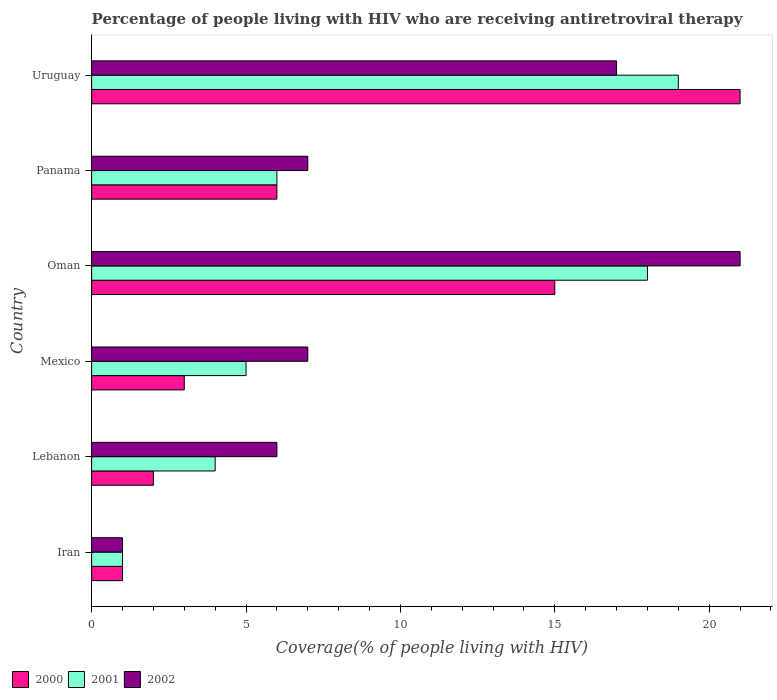How many different coloured bars are there?
Keep it short and to the point. 3. How many groups of bars are there?
Give a very brief answer. 6. How many bars are there on the 2nd tick from the top?
Your answer should be very brief. 3. What is the label of the 2nd group of bars from the top?
Your answer should be compact. Panama. Across all countries, what is the maximum percentage of the HIV infected people who are receiving antiretroviral therapy in 2000?
Your answer should be compact. 21. Across all countries, what is the minimum percentage of the HIV infected people who are receiving antiretroviral therapy in 2000?
Make the answer very short. 1. In which country was the percentage of the HIV infected people who are receiving antiretroviral therapy in 2000 maximum?
Offer a very short reply. Uruguay. In which country was the percentage of the HIV infected people who are receiving antiretroviral therapy in 2002 minimum?
Offer a very short reply. Iran. What is the average percentage of the HIV infected people who are receiving antiretroviral therapy in 2001 per country?
Offer a terse response. 8.83. In how many countries, is the percentage of the HIV infected people who are receiving antiretroviral therapy in 2002 greater than 5 %?
Ensure brevity in your answer.  5. What is the ratio of the percentage of the HIV infected people who are receiving antiretroviral therapy in 2000 in Panama to that in Uruguay?
Provide a succinct answer. 0.29. Is the percentage of the HIV infected people who are receiving antiretroviral therapy in 2000 in Iran less than that in Uruguay?
Your answer should be very brief. Yes. Is the difference between the percentage of the HIV infected people who are receiving antiretroviral therapy in 2001 in Mexico and Uruguay greater than the difference between the percentage of the HIV infected people who are receiving antiretroviral therapy in 2002 in Mexico and Uruguay?
Give a very brief answer. No. What is the difference between the highest and the lowest percentage of the HIV infected people who are receiving antiretroviral therapy in 2000?
Your response must be concise. 20. Is the sum of the percentage of the HIV infected people who are receiving antiretroviral therapy in 2000 in Iran and Panama greater than the maximum percentage of the HIV infected people who are receiving antiretroviral therapy in 2002 across all countries?
Keep it short and to the point. No. What does the 2nd bar from the top in Uruguay represents?
Your answer should be very brief. 2001. Are all the bars in the graph horizontal?
Ensure brevity in your answer.  Yes. How many countries are there in the graph?
Provide a short and direct response. 6. What is the difference between two consecutive major ticks on the X-axis?
Ensure brevity in your answer.  5. Are the values on the major ticks of X-axis written in scientific E-notation?
Make the answer very short. No. Does the graph contain any zero values?
Keep it short and to the point. No. Does the graph contain grids?
Offer a very short reply. No. How are the legend labels stacked?
Provide a succinct answer. Horizontal. What is the title of the graph?
Your response must be concise. Percentage of people living with HIV who are receiving antiretroviral therapy. Does "1985" appear as one of the legend labels in the graph?
Provide a short and direct response. No. What is the label or title of the X-axis?
Provide a short and direct response. Coverage(% of people living with HIV). What is the label or title of the Y-axis?
Your answer should be very brief. Country. What is the Coverage(% of people living with HIV) in 2001 in Iran?
Make the answer very short. 1. What is the Coverage(% of people living with HIV) of 2002 in Iran?
Provide a succinct answer. 1. What is the Coverage(% of people living with HIV) of 2000 in Lebanon?
Your answer should be very brief. 2. What is the Coverage(% of people living with HIV) in 2001 in Lebanon?
Your response must be concise. 4. What is the Coverage(% of people living with HIV) of 2002 in Lebanon?
Your answer should be compact. 6. What is the Coverage(% of people living with HIV) in 2000 in Mexico?
Ensure brevity in your answer.  3. What is the Coverage(% of people living with HIV) in 2001 in Mexico?
Offer a terse response. 5. What is the Coverage(% of people living with HIV) in 2002 in Mexico?
Give a very brief answer. 7. What is the Coverage(% of people living with HIV) in 2000 in Oman?
Ensure brevity in your answer.  15. What is the Coverage(% of people living with HIV) of 2001 in Panama?
Provide a succinct answer. 6. What is the Coverage(% of people living with HIV) of 2002 in Panama?
Offer a terse response. 7. What is the Coverage(% of people living with HIV) of 2002 in Uruguay?
Your response must be concise. 17. Across all countries, what is the maximum Coverage(% of people living with HIV) of 2000?
Provide a short and direct response. 21. Across all countries, what is the maximum Coverage(% of people living with HIV) of 2001?
Ensure brevity in your answer.  19. Across all countries, what is the minimum Coverage(% of people living with HIV) of 2002?
Keep it short and to the point. 1. What is the difference between the Coverage(% of people living with HIV) of 2001 in Iran and that in Lebanon?
Your answer should be compact. -3. What is the difference between the Coverage(% of people living with HIV) of 2002 in Iran and that in Lebanon?
Your answer should be very brief. -5. What is the difference between the Coverage(% of people living with HIV) of 2002 in Iran and that in Mexico?
Offer a very short reply. -6. What is the difference between the Coverage(% of people living with HIV) in 2000 in Iran and that in Oman?
Keep it short and to the point. -14. What is the difference between the Coverage(% of people living with HIV) of 2002 in Iran and that in Oman?
Offer a very short reply. -20. What is the difference between the Coverage(% of people living with HIV) of 2001 in Iran and that in Panama?
Make the answer very short. -5. What is the difference between the Coverage(% of people living with HIV) in 2000 in Lebanon and that in Mexico?
Make the answer very short. -1. What is the difference between the Coverage(% of people living with HIV) of 2002 in Lebanon and that in Mexico?
Give a very brief answer. -1. What is the difference between the Coverage(% of people living with HIV) of 2001 in Lebanon and that in Oman?
Ensure brevity in your answer.  -14. What is the difference between the Coverage(% of people living with HIV) in 2002 in Lebanon and that in Oman?
Provide a succinct answer. -15. What is the difference between the Coverage(% of people living with HIV) of 2000 in Lebanon and that in Uruguay?
Offer a terse response. -19. What is the difference between the Coverage(% of people living with HIV) in 2001 in Mexico and that in Panama?
Offer a very short reply. -1. What is the difference between the Coverage(% of people living with HIV) of 2002 in Mexico and that in Panama?
Provide a succinct answer. 0. What is the difference between the Coverage(% of people living with HIV) in 2002 in Mexico and that in Uruguay?
Your answer should be compact. -10. What is the difference between the Coverage(% of people living with HIV) in 2001 in Oman and that in Panama?
Your answer should be very brief. 12. What is the difference between the Coverage(% of people living with HIV) in 2002 in Oman and that in Panama?
Provide a short and direct response. 14. What is the difference between the Coverage(% of people living with HIV) in 2000 in Oman and that in Uruguay?
Make the answer very short. -6. What is the difference between the Coverage(% of people living with HIV) of 2001 in Oman and that in Uruguay?
Keep it short and to the point. -1. What is the difference between the Coverage(% of people living with HIV) in 2000 in Panama and that in Uruguay?
Your response must be concise. -15. What is the difference between the Coverage(% of people living with HIV) in 2002 in Panama and that in Uruguay?
Give a very brief answer. -10. What is the difference between the Coverage(% of people living with HIV) in 2000 in Iran and the Coverage(% of people living with HIV) in 2001 in Lebanon?
Offer a terse response. -3. What is the difference between the Coverage(% of people living with HIV) in 2001 in Iran and the Coverage(% of people living with HIV) in 2002 in Lebanon?
Keep it short and to the point. -5. What is the difference between the Coverage(% of people living with HIV) of 2000 in Iran and the Coverage(% of people living with HIV) of 2001 in Oman?
Keep it short and to the point. -17. What is the difference between the Coverage(% of people living with HIV) of 2000 in Iran and the Coverage(% of people living with HIV) of 2001 in Panama?
Make the answer very short. -5. What is the difference between the Coverage(% of people living with HIV) of 2000 in Iran and the Coverage(% of people living with HIV) of 2002 in Panama?
Your answer should be compact. -6. What is the difference between the Coverage(% of people living with HIV) in 2001 in Iran and the Coverage(% of people living with HIV) in 2002 in Panama?
Your answer should be very brief. -6. What is the difference between the Coverage(% of people living with HIV) of 2000 in Iran and the Coverage(% of people living with HIV) of 2001 in Uruguay?
Keep it short and to the point. -18. What is the difference between the Coverage(% of people living with HIV) in 2001 in Iran and the Coverage(% of people living with HIV) in 2002 in Uruguay?
Keep it short and to the point. -16. What is the difference between the Coverage(% of people living with HIV) of 2000 in Lebanon and the Coverage(% of people living with HIV) of 2001 in Mexico?
Keep it short and to the point. -3. What is the difference between the Coverage(% of people living with HIV) in 2000 in Lebanon and the Coverage(% of people living with HIV) in 2002 in Mexico?
Give a very brief answer. -5. What is the difference between the Coverage(% of people living with HIV) of 2000 in Lebanon and the Coverage(% of people living with HIV) of 2002 in Oman?
Give a very brief answer. -19. What is the difference between the Coverage(% of people living with HIV) of 2001 in Lebanon and the Coverage(% of people living with HIV) of 2002 in Oman?
Your answer should be very brief. -17. What is the difference between the Coverage(% of people living with HIV) in 2000 in Lebanon and the Coverage(% of people living with HIV) in 2001 in Panama?
Your answer should be compact. -4. What is the difference between the Coverage(% of people living with HIV) in 2000 in Lebanon and the Coverage(% of people living with HIV) in 2002 in Panama?
Make the answer very short. -5. What is the difference between the Coverage(% of people living with HIV) of 2000 in Lebanon and the Coverage(% of people living with HIV) of 2002 in Uruguay?
Offer a very short reply. -15. What is the difference between the Coverage(% of people living with HIV) of 2000 in Mexico and the Coverage(% of people living with HIV) of 2001 in Oman?
Keep it short and to the point. -15. What is the difference between the Coverage(% of people living with HIV) of 2000 in Mexico and the Coverage(% of people living with HIV) of 2002 in Oman?
Your answer should be compact. -18. What is the difference between the Coverage(% of people living with HIV) in 2001 in Mexico and the Coverage(% of people living with HIV) in 2002 in Oman?
Your response must be concise. -16. What is the difference between the Coverage(% of people living with HIV) in 2001 in Mexico and the Coverage(% of people living with HIV) in 2002 in Panama?
Your response must be concise. -2. What is the difference between the Coverage(% of people living with HIV) of 2000 in Mexico and the Coverage(% of people living with HIV) of 2001 in Uruguay?
Offer a terse response. -16. What is the difference between the Coverage(% of people living with HIV) in 2000 in Mexico and the Coverage(% of people living with HIV) in 2002 in Uruguay?
Keep it short and to the point. -14. What is the difference between the Coverage(% of people living with HIV) of 2001 in Mexico and the Coverage(% of people living with HIV) of 2002 in Uruguay?
Provide a succinct answer. -12. What is the difference between the Coverage(% of people living with HIV) in 2000 in Oman and the Coverage(% of people living with HIV) in 2001 in Panama?
Make the answer very short. 9. What is the difference between the Coverage(% of people living with HIV) in 2001 in Oman and the Coverage(% of people living with HIV) in 2002 in Panama?
Your answer should be very brief. 11. What is the difference between the Coverage(% of people living with HIV) in 2000 in Oman and the Coverage(% of people living with HIV) in 2001 in Uruguay?
Make the answer very short. -4. What is the difference between the Coverage(% of people living with HIV) in 2000 in Oman and the Coverage(% of people living with HIV) in 2002 in Uruguay?
Make the answer very short. -2. What is the difference between the Coverage(% of people living with HIV) of 2001 in Oman and the Coverage(% of people living with HIV) of 2002 in Uruguay?
Give a very brief answer. 1. What is the difference between the Coverage(% of people living with HIV) of 2001 in Panama and the Coverage(% of people living with HIV) of 2002 in Uruguay?
Your answer should be very brief. -11. What is the average Coverage(% of people living with HIV) of 2001 per country?
Make the answer very short. 8.83. What is the average Coverage(% of people living with HIV) in 2002 per country?
Provide a succinct answer. 9.83. What is the difference between the Coverage(% of people living with HIV) in 2000 and Coverage(% of people living with HIV) in 2001 in Iran?
Offer a terse response. 0. What is the difference between the Coverage(% of people living with HIV) of 2000 and Coverage(% of people living with HIV) of 2002 in Iran?
Provide a short and direct response. 0. What is the difference between the Coverage(% of people living with HIV) of 2000 and Coverage(% of people living with HIV) of 2002 in Lebanon?
Provide a short and direct response. -4. What is the difference between the Coverage(% of people living with HIV) in 2000 and Coverage(% of people living with HIV) in 2002 in Mexico?
Your response must be concise. -4. What is the difference between the Coverage(% of people living with HIV) in 2001 and Coverage(% of people living with HIV) in 2002 in Mexico?
Your answer should be compact. -2. What is the difference between the Coverage(% of people living with HIV) of 2000 and Coverage(% of people living with HIV) of 2002 in Oman?
Offer a terse response. -6. What is the difference between the Coverage(% of people living with HIV) of 2001 and Coverage(% of people living with HIV) of 2002 in Oman?
Give a very brief answer. -3. What is the difference between the Coverage(% of people living with HIV) in 2001 and Coverage(% of people living with HIV) in 2002 in Panama?
Your answer should be compact. -1. What is the difference between the Coverage(% of people living with HIV) of 2001 and Coverage(% of people living with HIV) of 2002 in Uruguay?
Give a very brief answer. 2. What is the ratio of the Coverage(% of people living with HIV) in 2000 in Iran to that in Lebanon?
Keep it short and to the point. 0.5. What is the ratio of the Coverage(% of people living with HIV) of 2002 in Iran to that in Lebanon?
Provide a short and direct response. 0.17. What is the ratio of the Coverage(% of people living with HIV) of 2002 in Iran to that in Mexico?
Your answer should be very brief. 0.14. What is the ratio of the Coverage(% of people living with HIV) in 2000 in Iran to that in Oman?
Offer a very short reply. 0.07. What is the ratio of the Coverage(% of people living with HIV) in 2001 in Iran to that in Oman?
Give a very brief answer. 0.06. What is the ratio of the Coverage(% of people living with HIV) in 2002 in Iran to that in Oman?
Keep it short and to the point. 0.05. What is the ratio of the Coverage(% of people living with HIV) in 2001 in Iran to that in Panama?
Offer a very short reply. 0.17. What is the ratio of the Coverage(% of people living with HIV) of 2002 in Iran to that in Panama?
Ensure brevity in your answer.  0.14. What is the ratio of the Coverage(% of people living with HIV) in 2000 in Iran to that in Uruguay?
Ensure brevity in your answer.  0.05. What is the ratio of the Coverage(% of people living with HIV) of 2001 in Iran to that in Uruguay?
Your response must be concise. 0.05. What is the ratio of the Coverage(% of people living with HIV) in 2002 in Iran to that in Uruguay?
Your answer should be compact. 0.06. What is the ratio of the Coverage(% of people living with HIV) of 2000 in Lebanon to that in Mexico?
Provide a short and direct response. 0.67. What is the ratio of the Coverage(% of people living with HIV) in 2001 in Lebanon to that in Mexico?
Make the answer very short. 0.8. What is the ratio of the Coverage(% of people living with HIV) in 2002 in Lebanon to that in Mexico?
Offer a terse response. 0.86. What is the ratio of the Coverage(% of people living with HIV) in 2000 in Lebanon to that in Oman?
Keep it short and to the point. 0.13. What is the ratio of the Coverage(% of people living with HIV) of 2001 in Lebanon to that in Oman?
Keep it short and to the point. 0.22. What is the ratio of the Coverage(% of people living with HIV) in 2002 in Lebanon to that in Oman?
Your answer should be compact. 0.29. What is the ratio of the Coverage(% of people living with HIV) of 2002 in Lebanon to that in Panama?
Your answer should be compact. 0.86. What is the ratio of the Coverage(% of people living with HIV) in 2000 in Lebanon to that in Uruguay?
Offer a very short reply. 0.1. What is the ratio of the Coverage(% of people living with HIV) of 2001 in Lebanon to that in Uruguay?
Make the answer very short. 0.21. What is the ratio of the Coverage(% of people living with HIV) of 2002 in Lebanon to that in Uruguay?
Provide a succinct answer. 0.35. What is the ratio of the Coverage(% of people living with HIV) of 2000 in Mexico to that in Oman?
Provide a succinct answer. 0.2. What is the ratio of the Coverage(% of people living with HIV) of 2001 in Mexico to that in Oman?
Keep it short and to the point. 0.28. What is the ratio of the Coverage(% of people living with HIV) in 2000 in Mexico to that in Panama?
Ensure brevity in your answer.  0.5. What is the ratio of the Coverage(% of people living with HIV) of 2001 in Mexico to that in Panama?
Offer a terse response. 0.83. What is the ratio of the Coverage(% of people living with HIV) in 2002 in Mexico to that in Panama?
Offer a terse response. 1. What is the ratio of the Coverage(% of people living with HIV) of 2000 in Mexico to that in Uruguay?
Give a very brief answer. 0.14. What is the ratio of the Coverage(% of people living with HIV) in 2001 in Mexico to that in Uruguay?
Provide a succinct answer. 0.26. What is the ratio of the Coverage(% of people living with HIV) in 2002 in Mexico to that in Uruguay?
Keep it short and to the point. 0.41. What is the ratio of the Coverage(% of people living with HIV) of 2000 in Oman to that in Panama?
Provide a succinct answer. 2.5. What is the ratio of the Coverage(% of people living with HIV) in 2002 in Oman to that in Uruguay?
Provide a short and direct response. 1.24. What is the ratio of the Coverage(% of people living with HIV) of 2000 in Panama to that in Uruguay?
Keep it short and to the point. 0.29. What is the ratio of the Coverage(% of people living with HIV) of 2001 in Panama to that in Uruguay?
Your response must be concise. 0.32. What is the ratio of the Coverage(% of people living with HIV) in 2002 in Panama to that in Uruguay?
Offer a terse response. 0.41. What is the difference between the highest and the second highest Coverage(% of people living with HIV) in 2001?
Your answer should be very brief. 1. What is the difference between the highest and the lowest Coverage(% of people living with HIV) in 2000?
Your answer should be very brief. 20. What is the difference between the highest and the lowest Coverage(% of people living with HIV) in 2002?
Offer a very short reply. 20. 